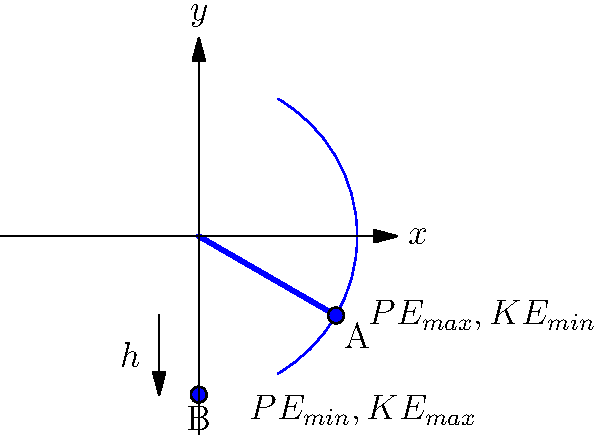In a grandfather clock, a simple pendulum demonstrates the conservation of energy. At point A, the pendulum is at its highest position, and at point B, it's at its lowest. If the pendulum bob has a mass of 0.5 kg and the vertical distance between points A and B is 0.2 m, calculate the maximum kinetic energy of the pendulum bob. Assume there is no energy loss due to friction or air resistance. Let's approach this step-by-step:

1) The conservation of energy states that the total energy of an isolated system remains constant. In this case, the total energy is the sum of potential energy (PE) and kinetic energy (KE).

2) At the highest point (A):
   - PE is maximum
   - KE is minimum (zero)

3) At the lowest point (B):
   - PE is minimum (zero)
   - KE is maximum

4) The change in potential energy from A to B equals the maximum kinetic energy at B:

   $PE_A - PE_B = KE_{max}$

5) We can calculate the change in potential energy:
   $\Delta PE = mgh$
   where $m$ is mass, $g$ is acceleration due to gravity (9.8 m/s²), and $h$ is height difference

6) Plugging in the values:
   $KE_{max} = mgh = 0.5 \text{ kg} \times 9.8 \text{ m/s}^2 \times 0.2 \text{ m}$

7) Calculate:
   $KE_{max} = 0.98 \text{ J}$

This result shows how potential energy at the highest point is converted to kinetic energy at the lowest point, demonstrating the conservation of energy in a simple pendulum system.
Answer: 0.98 J 